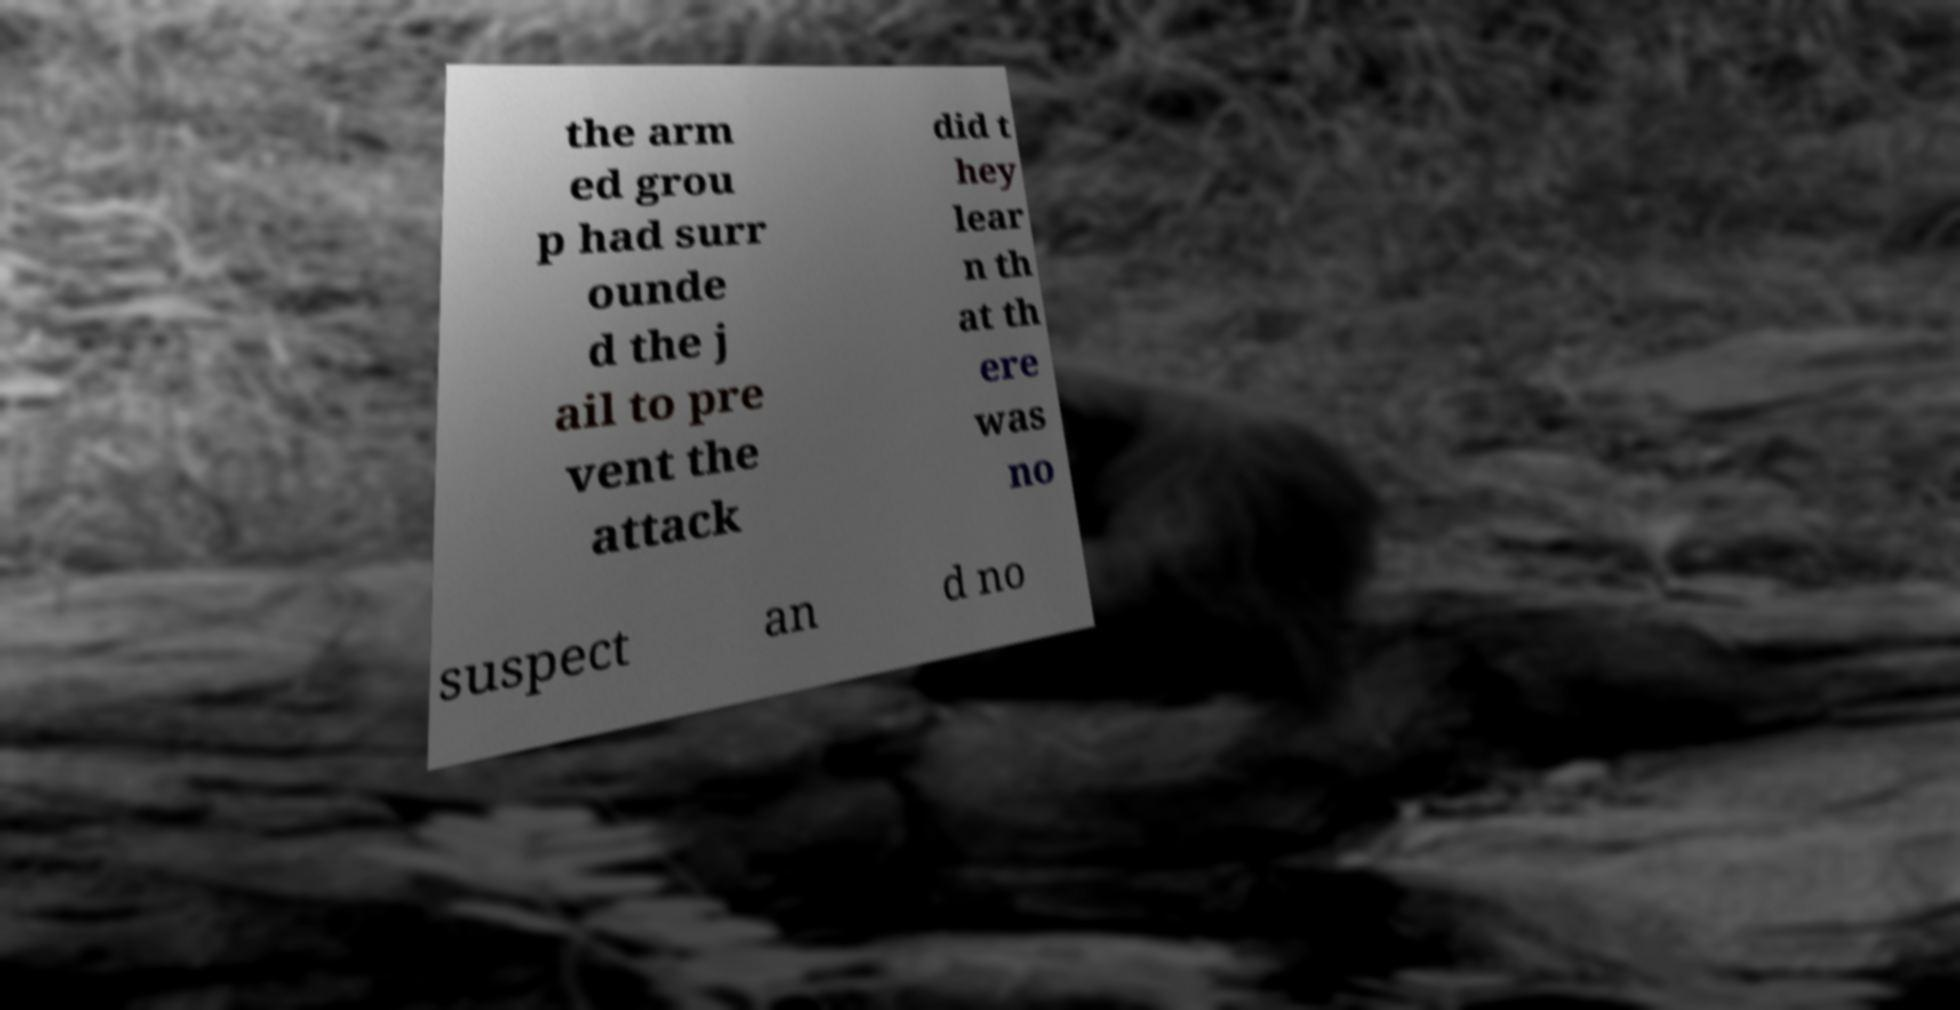Can you read and provide the text displayed in the image?This photo seems to have some interesting text. Can you extract and type it out for me? the arm ed grou p had surr ounde d the j ail to pre vent the attack did t hey lear n th at th ere was no suspect an d no 